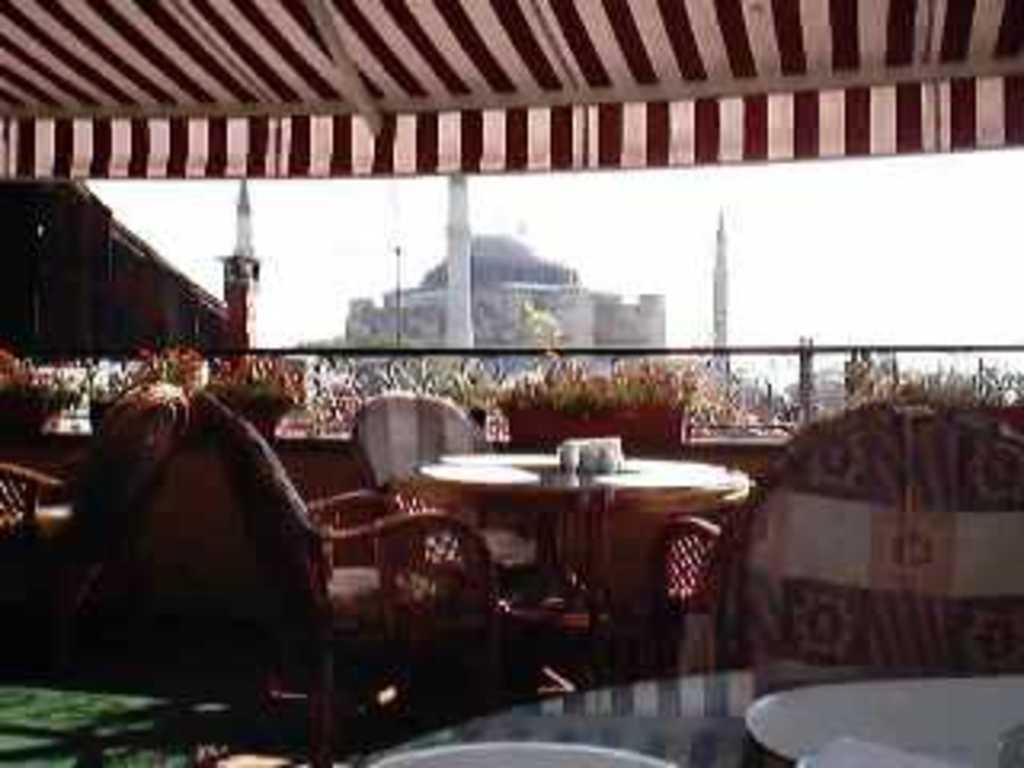Can you describe this image briefly? In this image there are tables, on that tables there are plates and glasses around the tables there are chairs, in the background there are plants and glass wall and buildings, at top there is tent. 